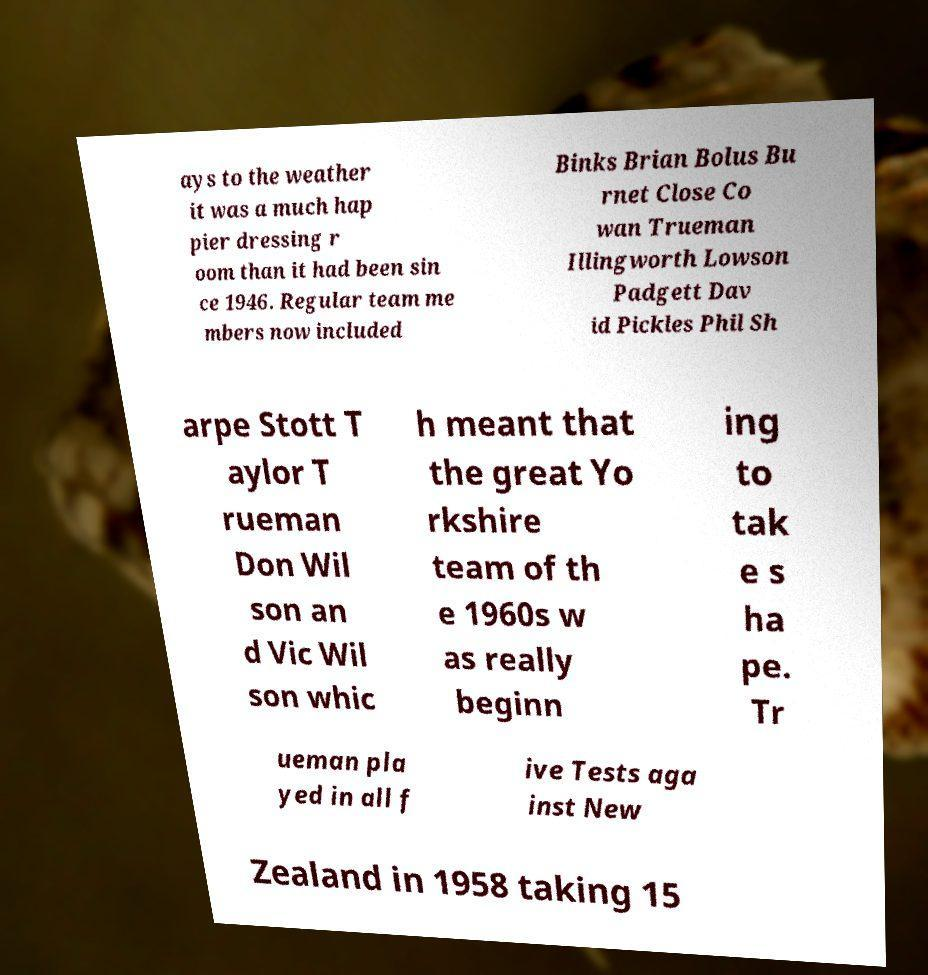For documentation purposes, I need the text within this image transcribed. Could you provide that? ays to the weather it was a much hap pier dressing r oom than it had been sin ce 1946. Regular team me mbers now included Binks Brian Bolus Bu rnet Close Co wan Trueman Illingworth Lowson Padgett Dav id Pickles Phil Sh arpe Stott T aylor T rueman Don Wil son an d Vic Wil son whic h meant that the great Yo rkshire team of th e 1960s w as really beginn ing to tak e s ha pe. Tr ueman pla yed in all f ive Tests aga inst New Zealand in 1958 taking 15 